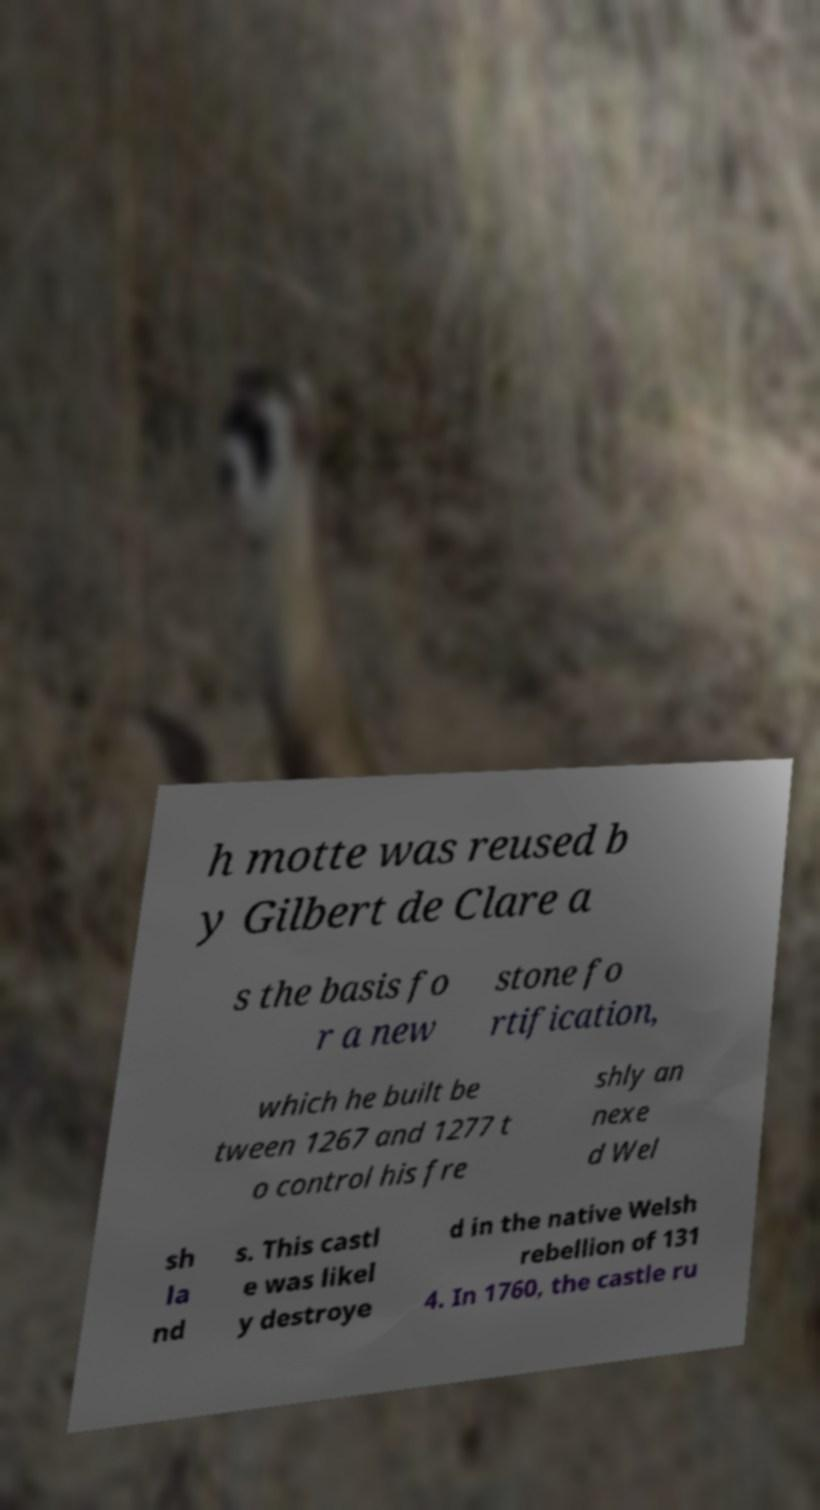Could you extract and type out the text from this image? h motte was reused b y Gilbert de Clare a s the basis fo r a new stone fo rtification, which he built be tween 1267 and 1277 t o control his fre shly an nexe d Wel sh la nd s. This castl e was likel y destroye d in the native Welsh rebellion of 131 4. In 1760, the castle ru 